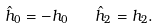Convert formula to latex. <formula><loc_0><loc_0><loc_500><loc_500>\hat { h } _ { 0 } = - h _ { 0 } \quad \hat { h } _ { 2 } = h _ { 2 } .</formula> 